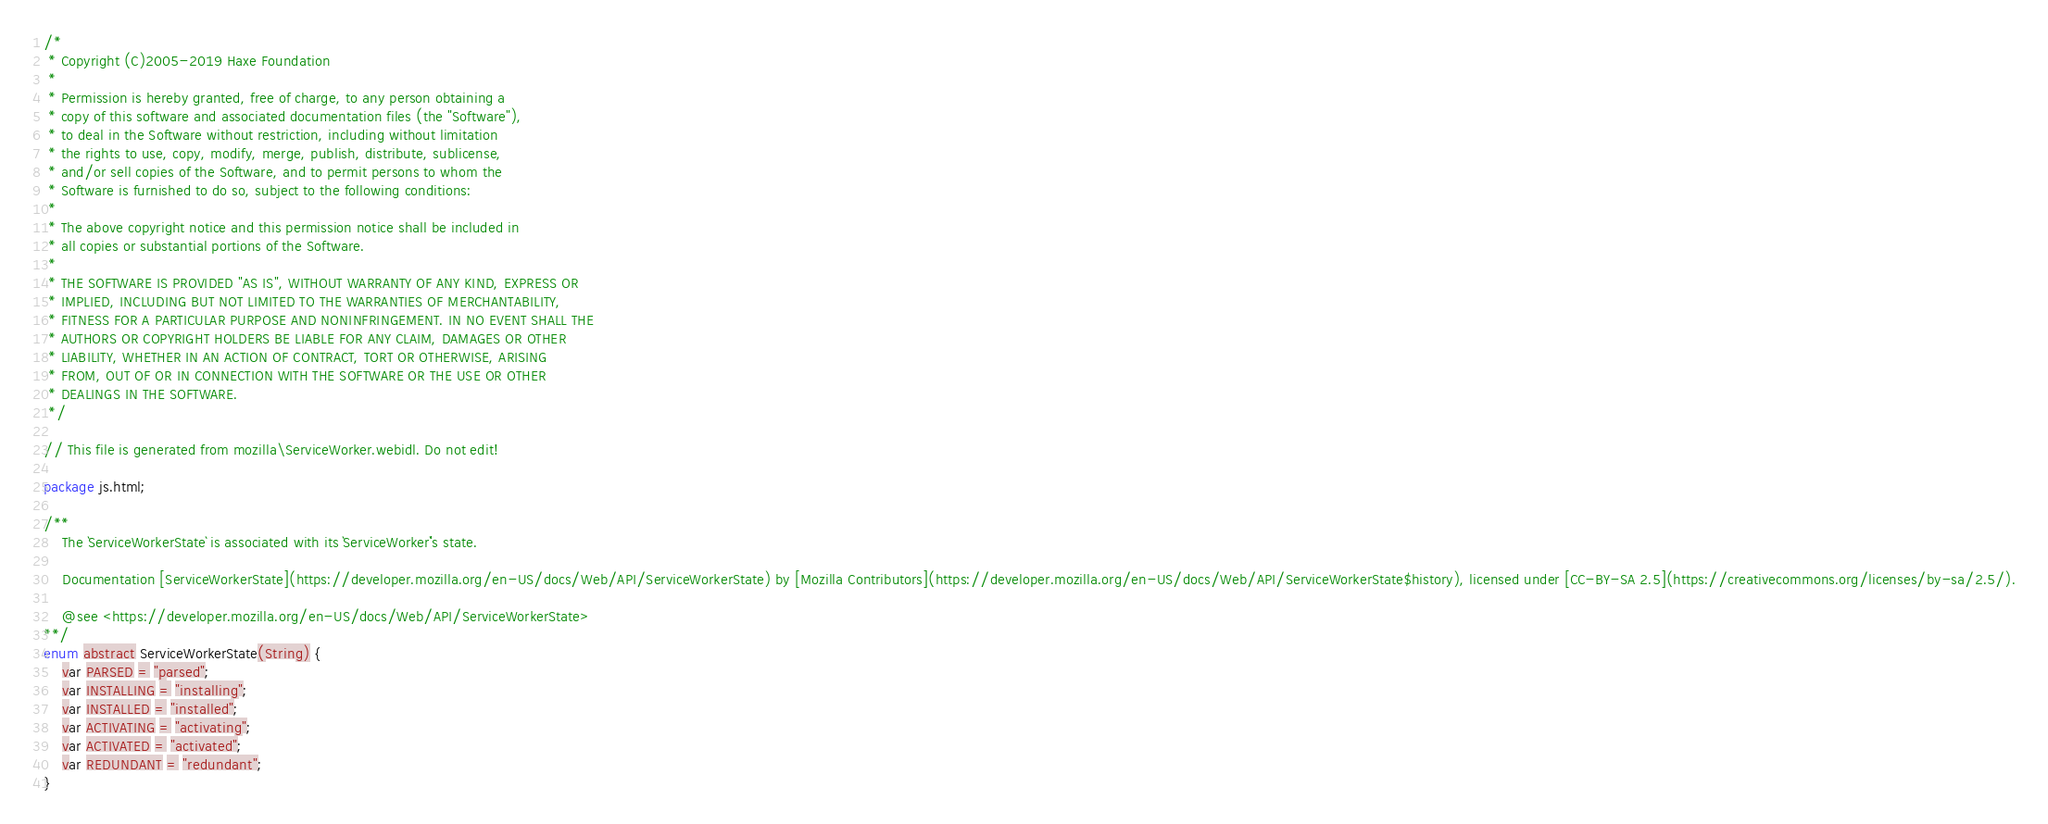Convert code to text. <code><loc_0><loc_0><loc_500><loc_500><_Haxe_>/*
 * Copyright (C)2005-2019 Haxe Foundation
 *
 * Permission is hereby granted, free of charge, to any person obtaining a
 * copy of this software and associated documentation files (the "Software"),
 * to deal in the Software without restriction, including without limitation
 * the rights to use, copy, modify, merge, publish, distribute, sublicense,
 * and/or sell copies of the Software, and to permit persons to whom the
 * Software is furnished to do so, subject to the following conditions:
 *
 * The above copyright notice and this permission notice shall be included in
 * all copies or substantial portions of the Software.
 *
 * THE SOFTWARE IS PROVIDED "AS IS", WITHOUT WARRANTY OF ANY KIND, EXPRESS OR
 * IMPLIED, INCLUDING BUT NOT LIMITED TO THE WARRANTIES OF MERCHANTABILITY,
 * FITNESS FOR A PARTICULAR PURPOSE AND NONINFRINGEMENT. IN NO EVENT SHALL THE
 * AUTHORS OR COPYRIGHT HOLDERS BE LIABLE FOR ANY CLAIM, DAMAGES OR OTHER
 * LIABILITY, WHETHER IN AN ACTION OF CONTRACT, TORT OR OTHERWISE, ARISING
 * FROM, OUT OF OR IN CONNECTION WITH THE SOFTWARE OR THE USE OR OTHER
 * DEALINGS IN THE SOFTWARE.
 */

// This file is generated from mozilla\ServiceWorker.webidl. Do not edit!

package js.html;

/**
	The `ServiceWorkerState` is associated with its `ServiceWorker`'s state.

	Documentation [ServiceWorkerState](https://developer.mozilla.org/en-US/docs/Web/API/ServiceWorkerState) by [Mozilla Contributors](https://developer.mozilla.org/en-US/docs/Web/API/ServiceWorkerState$history), licensed under [CC-BY-SA 2.5](https://creativecommons.org/licenses/by-sa/2.5/).

	@see <https://developer.mozilla.org/en-US/docs/Web/API/ServiceWorkerState>
**/
enum abstract ServiceWorkerState(String) {
	var PARSED = "parsed";
	var INSTALLING = "installing";
	var INSTALLED = "installed";
	var ACTIVATING = "activating";
	var ACTIVATED = "activated";
	var REDUNDANT = "redundant";
}</code> 